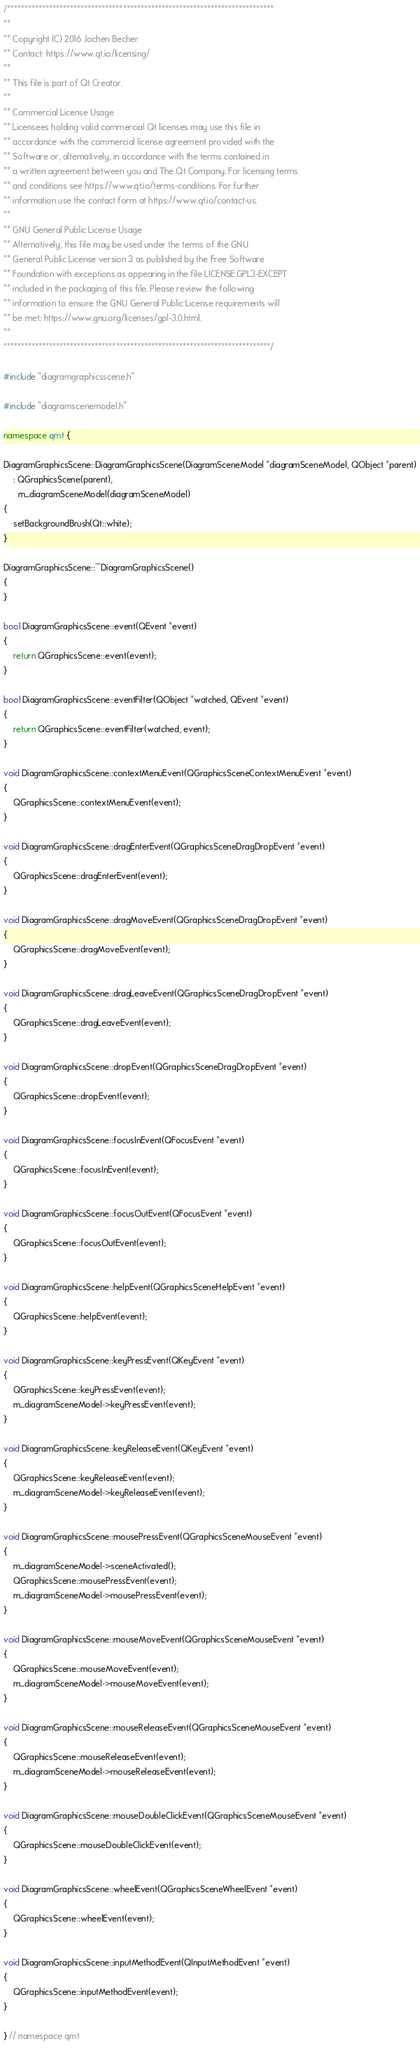<code> <loc_0><loc_0><loc_500><loc_500><_C++_>/****************************************************************************
**
** Copyright (C) 2016 Jochen Becher
** Contact: https://www.qt.io/licensing/
**
** This file is part of Qt Creator.
**
** Commercial License Usage
** Licensees holding valid commercial Qt licenses may use this file in
** accordance with the commercial license agreement provided with the
** Software or, alternatively, in accordance with the terms contained in
** a written agreement between you and The Qt Company. For licensing terms
** and conditions see https://www.qt.io/terms-conditions. For further
** information use the contact form at https://www.qt.io/contact-us.
**
** GNU General Public License Usage
** Alternatively, this file may be used under the terms of the GNU
** General Public License version 3 as published by the Free Software
** Foundation with exceptions as appearing in the file LICENSE.GPL3-EXCEPT
** included in the packaging of this file. Please review the following
** information to ensure the GNU General Public License requirements will
** be met: https://www.gnu.org/licenses/gpl-3.0.html.
**
****************************************************************************/

#include "diagramgraphicsscene.h"

#include "diagramscenemodel.h"

namespace qmt {

DiagramGraphicsScene::DiagramGraphicsScene(DiagramSceneModel *diagramSceneModel, QObject *parent)
    : QGraphicsScene(parent),
      m_diagramSceneModel(diagramSceneModel)
{
    setBackgroundBrush(Qt::white);
}

DiagramGraphicsScene::~DiagramGraphicsScene()
{
}

bool DiagramGraphicsScene::event(QEvent *event)
{
    return QGraphicsScene::event(event);
}

bool DiagramGraphicsScene::eventFilter(QObject *watched, QEvent *event)
{
    return QGraphicsScene::eventFilter(watched, event);
}

void DiagramGraphicsScene::contextMenuEvent(QGraphicsSceneContextMenuEvent *event)
{
    QGraphicsScene::contextMenuEvent(event);
}

void DiagramGraphicsScene::dragEnterEvent(QGraphicsSceneDragDropEvent *event)
{
    QGraphicsScene::dragEnterEvent(event);
}

void DiagramGraphicsScene::dragMoveEvent(QGraphicsSceneDragDropEvent *event)
{
    QGraphicsScene::dragMoveEvent(event);
}

void DiagramGraphicsScene::dragLeaveEvent(QGraphicsSceneDragDropEvent *event)
{
    QGraphicsScene::dragLeaveEvent(event);
}

void DiagramGraphicsScene::dropEvent(QGraphicsSceneDragDropEvent *event)
{
    QGraphicsScene::dropEvent(event);
}

void DiagramGraphicsScene::focusInEvent(QFocusEvent *event)
{
    QGraphicsScene::focusInEvent(event);
}

void DiagramGraphicsScene::focusOutEvent(QFocusEvent *event)
{
    QGraphicsScene::focusOutEvent(event);
}

void DiagramGraphicsScene::helpEvent(QGraphicsSceneHelpEvent *event)
{
    QGraphicsScene::helpEvent(event);
}

void DiagramGraphicsScene::keyPressEvent(QKeyEvent *event)
{
    QGraphicsScene::keyPressEvent(event);
    m_diagramSceneModel->keyPressEvent(event);
}

void DiagramGraphicsScene::keyReleaseEvent(QKeyEvent *event)
{
    QGraphicsScene::keyReleaseEvent(event);
    m_diagramSceneModel->keyReleaseEvent(event);
}

void DiagramGraphicsScene::mousePressEvent(QGraphicsSceneMouseEvent *event)
{
    m_diagramSceneModel->sceneActivated();
    QGraphicsScene::mousePressEvent(event);
    m_diagramSceneModel->mousePressEvent(event);
}

void DiagramGraphicsScene::mouseMoveEvent(QGraphicsSceneMouseEvent *event)
{
    QGraphicsScene::mouseMoveEvent(event);
    m_diagramSceneModel->mouseMoveEvent(event);
}

void DiagramGraphicsScene::mouseReleaseEvent(QGraphicsSceneMouseEvent *event)
{
    QGraphicsScene::mouseReleaseEvent(event);
    m_diagramSceneModel->mouseReleaseEvent(event);
}

void DiagramGraphicsScene::mouseDoubleClickEvent(QGraphicsSceneMouseEvent *event)
{
    QGraphicsScene::mouseDoubleClickEvent(event);
}

void DiagramGraphicsScene::wheelEvent(QGraphicsSceneWheelEvent *event)
{
    QGraphicsScene::wheelEvent(event);
}

void DiagramGraphicsScene::inputMethodEvent(QInputMethodEvent *event)
{
    QGraphicsScene::inputMethodEvent(event);
}

} // namespace qmt
</code> 